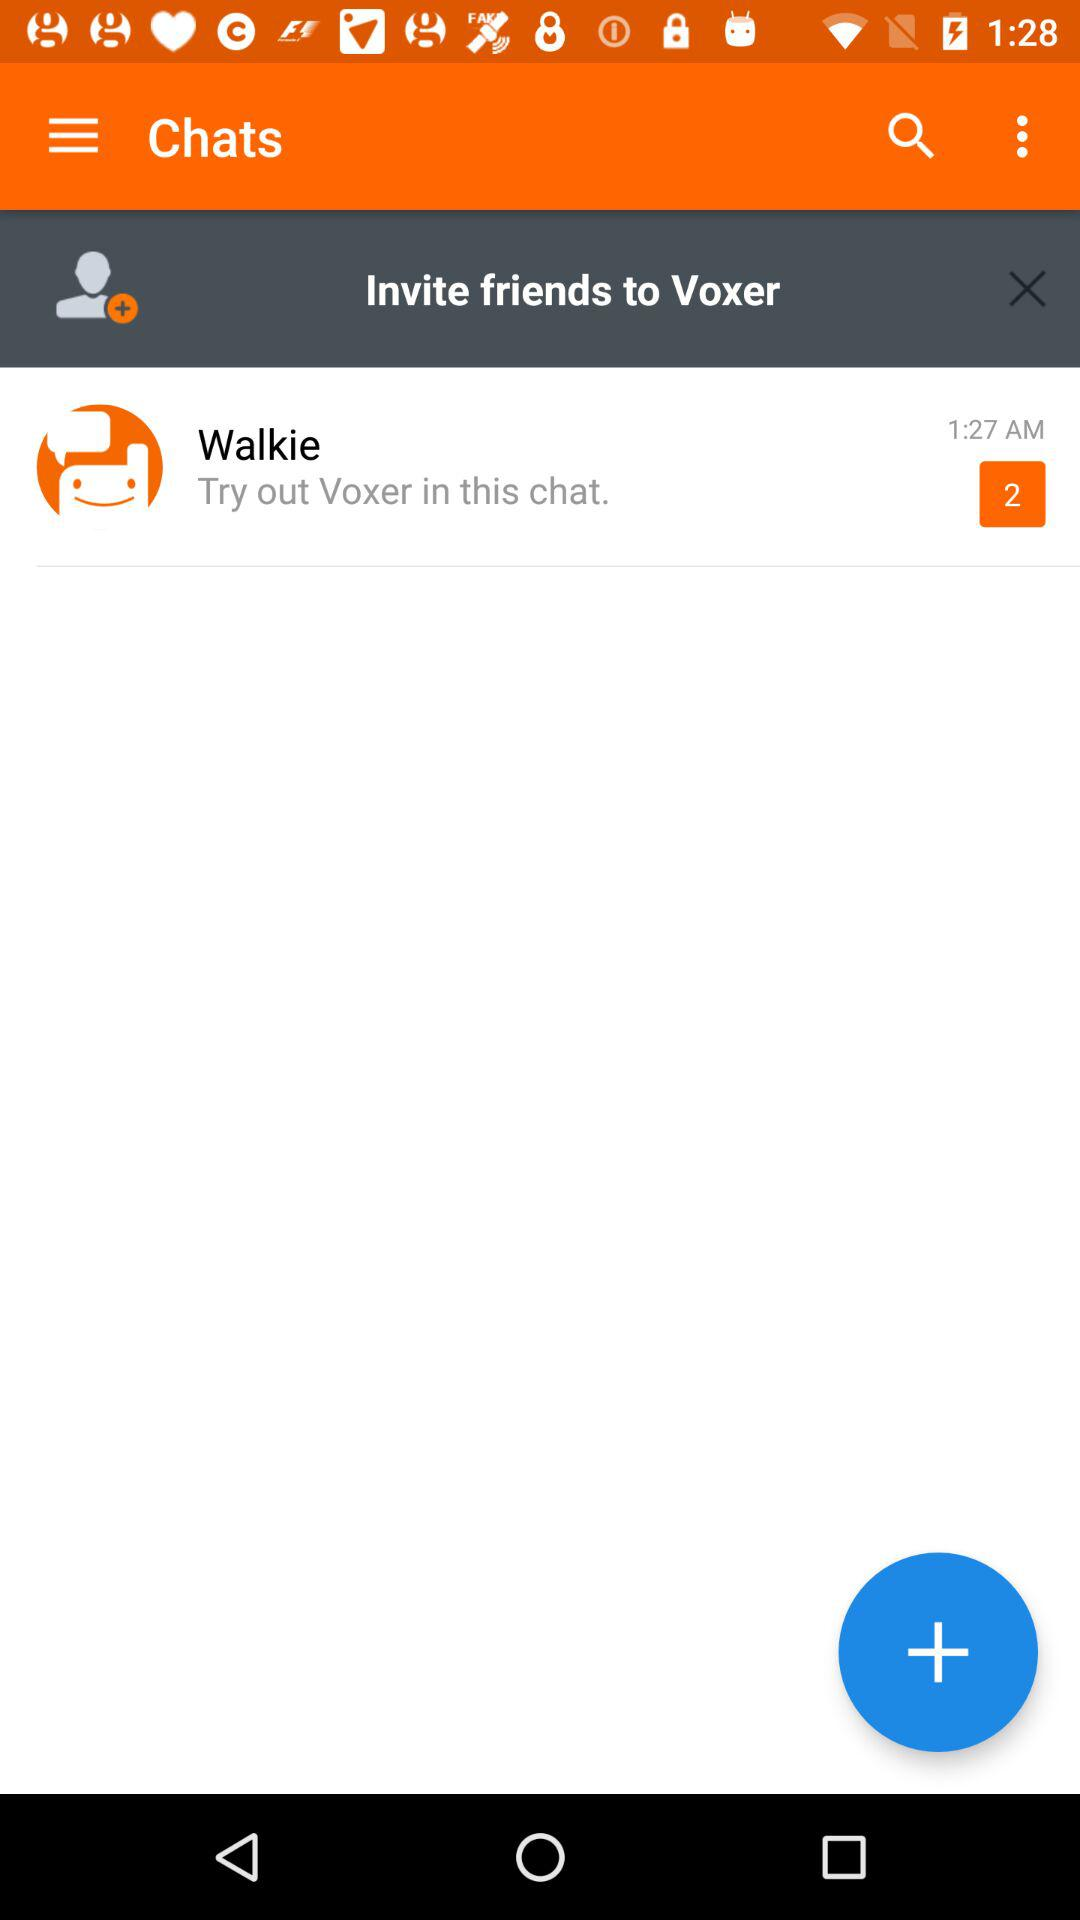How many unread messages are there from Walkie? There are 2 unread messages. 